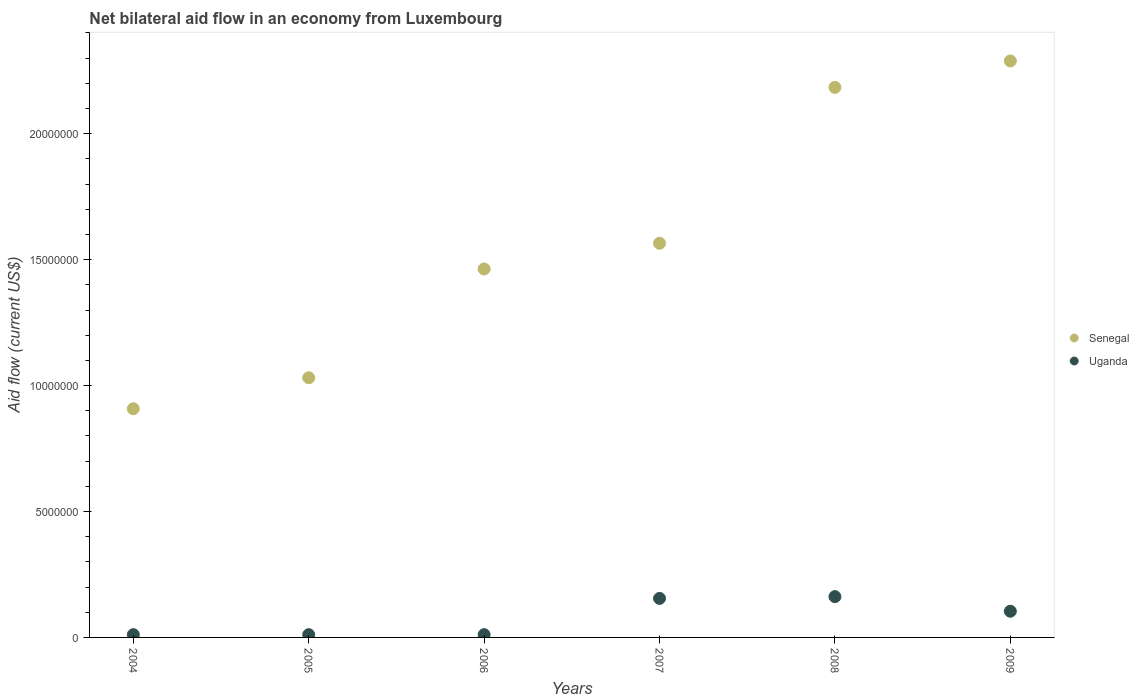How many different coloured dotlines are there?
Provide a succinct answer. 2. Is the number of dotlines equal to the number of legend labels?
Keep it short and to the point. Yes. What is the net bilateral aid flow in Senegal in 2008?
Ensure brevity in your answer.  2.18e+07. Across all years, what is the maximum net bilateral aid flow in Uganda?
Provide a short and direct response. 1.62e+06. Across all years, what is the minimum net bilateral aid flow in Senegal?
Your response must be concise. 9.08e+06. In which year was the net bilateral aid flow in Uganda minimum?
Offer a very short reply. 2004. What is the total net bilateral aid flow in Uganda in the graph?
Offer a very short reply. 4.54e+06. What is the difference between the net bilateral aid flow in Senegal in 2008 and that in 2009?
Make the answer very short. -1.05e+06. What is the difference between the net bilateral aid flow in Uganda in 2006 and the net bilateral aid flow in Senegal in 2009?
Keep it short and to the point. -2.28e+07. What is the average net bilateral aid flow in Uganda per year?
Offer a very short reply. 7.57e+05. In the year 2004, what is the difference between the net bilateral aid flow in Uganda and net bilateral aid flow in Senegal?
Provide a short and direct response. -8.97e+06. In how many years, is the net bilateral aid flow in Uganda greater than 17000000 US$?
Ensure brevity in your answer.  0. What is the ratio of the net bilateral aid flow in Uganda in 2004 to that in 2008?
Keep it short and to the point. 0.07. What is the difference between the highest and the second highest net bilateral aid flow in Senegal?
Provide a short and direct response. 1.05e+06. What is the difference between the highest and the lowest net bilateral aid flow in Senegal?
Provide a succinct answer. 1.38e+07. Is the sum of the net bilateral aid flow in Senegal in 2006 and 2008 greater than the maximum net bilateral aid flow in Uganda across all years?
Offer a terse response. Yes. Does the net bilateral aid flow in Uganda monotonically increase over the years?
Ensure brevity in your answer.  No. Is the net bilateral aid flow in Senegal strictly greater than the net bilateral aid flow in Uganda over the years?
Your answer should be very brief. Yes. How many dotlines are there?
Offer a terse response. 2. How many years are there in the graph?
Your answer should be compact. 6. Are the values on the major ticks of Y-axis written in scientific E-notation?
Provide a short and direct response. No. Does the graph contain any zero values?
Your answer should be very brief. No. Does the graph contain grids?
Ensure brevity in your answer.  No. How many legend labels are there?
Provide a short and direct response. 2. What is the title of the graph?
Your answer should be very brief. Net bilateral aid flow in an economy from Luxembourg. What is the label or title of the X-axis?
Give a very brief answer. Years. What is the label or title of the Y-axis?
Give a very brief answer. Aid flow (current US$). What is the Aid flow (current US$) of Senegal in 2004?
Your answer should be compact. 9.08e+06. What is the Aid flow (current US$) of Uganda in 2004?
Ensure brevity in your answer.  1.10e+05. What is the Aid flow (current US$) of Senegal in 2005?
Ensure brevity in your answer.  1.03e+07. What is the Aid flow (current US$) of Senegal in 2006?
Provide a succinct answer. 1.46e+07. What is the Aid flow (current US$) of Senegal in 2007?
Make the answer very short. 1.56e+07. What is the Aid flow (current US$) of Uganda in 2007?
Your answer should be very brief. 1.55e+06. What is the Aid flow (current US$) of Senegal in 2008?
Your answer should be very brief. 2.18e+07. What is the Aid flow (current US$) in Uganda in 2008?
Ensure brevity in your answer.  1.62e+06. What is the Aid flow (current US$) in Senegal in 2009?
Make the answer very short. 2.29e+07. What is the Aid flow (current US$) in Uganda in 2009?
Keep it short and to the point. 1.04e+06. Across all years, what is the maximum Aid flow (current US$) in Senegal?
Ensure brevity in your answer.  2.29e+07. Across all years, what is the maximum Aid flow (current US$) of Uganda?
Ensure brevity in your answer.  1.62e+06. Across all years, what is the minimum Aid flow (current US$) in Senegal?
Your answer should be compact. 9.08e+06. What is the total Aid flow (current US$) in Senegal in the graph?
Your response must be concise. 9.44e+07. What is the total Aid flow (current US$) of Uganda in the graph?
Provide a succinct answer. 4.54e+06. What is the difference between the Aid flow (current US$) in Senegal in 2004 and that in 2005?
Your answer should be very brief. -1.23e+06. What is the difference between the Aid flow (current US$) in Senegal in 2004 and that in 2006?
Keep it short and to the point. -5.55e+06. What is the difference between the Aid flow (current US$) of Senegal in 2004 and that in 2007?
Ensure brevity in your answer.  -6.57e+06. What is the difference between the Aid flow (current US$) in Uganda in 2004 and that in 2007?
Give a very brief answer. -1.44e+06. What is the difference between the Aid flow (current US$) of Senegal in 2004 and that in 2008?
Offer a terse response. -1.28e+07. What is the difference between the Aid flow (current US$) in Uganda in 2004 and that in 2008?
Ensure brevity in your answer.  -1.51e+06. What is the difference between the Aid flow (current US$) of Senegal in 2004 and that in 2009?
Make the answer very short. -1.38e+07. What is the difference between the Aid flow (current US$) of Uganda in 2004 and that in 2009?
Make the answer very short. -9.30e+05. What is the difference between the Aid flow (current US$) of Senegal in 2005 and that in 2006?
Give a very brief answer. -4.32e+06. What is the difference between the Aid flow (current US$) of Senegal in 2005 and that in 2007?
Give a very brief answer. -5.34e+06. What is the difference between the Aid flow (current US$) of Uganda in 2005 and that in 2007?
Give a very brief answer. -1.44e+06. What is the difference between the Aid flow (current US$) in Senegal in 2005 and that in 2008?
Provide a succinct answer. -1.15e+07. What is the difference between the Aid flow (current US$) of Uganda in 2005 and that in 2008?
Provide a short and direct response. -1.51e+06. What is the difference between the Aid flow (current US$) of Senegal in 2005 and that in 2009?
Offer a very short reply. -1.26e+07. What is the difference between the Aid flow (current US$) in Uganda in 2005 and that in 2009?
Keep it short and to the point. -9.30e+05. What is the difference between the Aid flow (current US$) of Senegal in 2006 and that in 2007?
Keep it short and to the point. -1.02e+06. What is the difference between the Aid flow (current US$) in Uganda in 2006 and that in 2007?
Ensure brevity in your answer.  -1.44e+06. What is the difference between the Aid flow (current US$) of Senegal in 2006 and that in 2008?
Give a very brief answer. -7.21e+06. What is the difference between the Aid flow (current US$) in Uganda in 2006 and that in 2008?
Provide a succinct answer. -1.51e+06. What is the difference between the Aid flow (current US$) in Senegal in 2006 and that in 2009?
Offer a terse response. -8.26e+06. What is the difference between the Aid flow (current US$) of Uganda in 2006 and that in 2009?
Your answer should be very brief. -9.30e+05. What is the difference between the Aid flow (current US$) of Senegal in 2007 and that in 2008?
Offer a terse response. -6.19e+06. What is the difference between the Aid flow (current US$) of Senegal in 2007 and that in 2009?
Your response must be concise. -7.24e+06. What is the difference between the Aid flow (current US$) of Uganda in 2007 and that in 2009?
Make the answer very short. 5.10e+05. What is the difference between the Aid flow (current US$) of Senegal in 2008 and that in 2009?
Keep it short and to the point. -1.05e+06. What is the difference between the Aid flow (current US$) of Uganda in 2008 and that in 2009?
Make the answer very short. 5.80e+05. What is the difference between the Aid flow (current US$) of Senegal in 2004 and the Aid flow (current US$) of Uganda in 2005?
Provide a succinct answer. 8.97e+06. What is the difference between the Aid flow (current US$) in Senegal in 2004 and the Aid flow (current US$) in Uganda in 2006?
Your response must be concise. 8.97e+06. What is the difference between the Aid flow (current US$) in Senegal in 2004 and the Aid flow (current US$) in Uganda in 2007?
Make the answer very short. 7.53e+06. What is the difference between the Aid flow (current US$) of Senegal in 2004 and the Aid flow (current US$) of Uganda in 2008?
Give a very brief answer. 7.46e+06. What is the difference between the Aid flow (current US$) of Senegal in 2004 and the Aid flow (current US$) of Uganda in 2009?
Your answer should be very brief. 8.04e+06. What is the difference between the Aid flow (current US$) of Senegal in 2005 and the Aid flow (current US$) of Uganda in 2006?
Provide a short and direct response. 1.02e+07. What is the difference between the Aid flow (current US$) of Senegal in 2005 and the Aid flow (current US$) of Uganda in 2007?
Your answer should be very brief. 8.76e+06. What is the difference between the Aid flow (current US$) in Senegal in 2005 and the Aid flow (current US$) in Uganda in 2008?
Provide a succinct answer. 8.69e+06. What is the difference between the Aid flow (current US$) in Senegal in 2005 and the Aid flow (current US$) in Uganda in 2009?
Your answer should be very brief. 9.27e+06. What is the difference between the Aid flow (current US$) in Senegal in 2006 and the Aid flow (current US$) in Uganda in 2007?
Keep it short and to the point. 1.31e+07. What is the difference between the Aid flow (current US$) in Senegal in 2006 and the Aid flow (current US$) in Uganda in 2008?
Provide a short and direct response. 1.30e+07. What is the difference between the Aid flow (current US$) of Senegal in 2006 and the Aid flow (current US$) of Uganda in 2009?
Give a very brief answer. 1.36e+07. What is the difference between the Aid flow (current US$) of Senegal in 2007 and the Aid flow (current US$) of Uganda in 2008?
Provide a succinct answer. 1.40e+07. What is the difference between the Aid flow (current US$) of Senegal in 2007 and the Aid flow (current US$) of Uganda in 2009?
Your response must be concise. 1.46e+07. What is the difference between the Aid flow (current US$) of Senegal in 2008 and the Aid flow (current US$) of Uganda in 2009?
Offer a terse response. 2.08e+07. What is the average Aid flow (current US$) of Senegal per year?
Provide a short and direct response. 1.57e+07. What is the average Aid flow (current US$) of Uganda per year?
Your answer should be compact. 7.57e+05. In the year 2004, what is the difference between the Aid flow (current US$) of Senegal and Aid flow (current US$) of Uganda?
Ensure brevity in your answer.  8.97e+06. In the year 2005, what is the difference between the Aid flow (current US$) of Senegal and Aid flow (current US$) of Uganda?
Provide a succinct answer. 1.02e+07. In the year 2006, what is the difference between the Aid flow (current US$) in Senegal and Aid flow (current US$) in Uganda?
Ensure brevity in your answer.  1.45e+07. In the year 2007, what is the difference between the Aid flow (current US$) in Senegal and Aid flow (current US$) in Uganda?
Your response must be concise. 1.41e+07. In the year 2008, what is the difference between the Aid flow (current US$) of Senegal and Aid flow (current US$) of Uganda?
Provide a succinct answer. 2.02e+07. In the year 2009, what is the difference between the Aid flow (current US$) of Senegal and Aid flow (current US$) of Uganda?
Your answer should be compact. 2.18e+07. What is the ratio of the Aid flow (current US$) of Senegal in 2004 to that in 2005?
Your response must be concise. 0.88. What is the ratio of the Aid flow (current US$) in Uganda in 2004 to that in 2005?
Offer a very short reply. 1. What is the ratio of the Aid flow (current US$) of Senegal in 2004 to that in 2006?
Your answer should be compact. 0.62. What is the ratio of the Aid flow (current US$) of Senegal in 2004 to that in 2007?
Provide a short and direct response. 0.58. What is the ratio of the Aid flow (current US$) in Uganda in 2004 to that in 2007?
Your answer should be compact. 0.07. What is the ratio of the Aid flow (current US$) in Senegal in 2004 to that in 2008?
Ensure brevity in your answer.  0.42. What is the ratio of the Aid flow (current US$) of Uganda in 2004 to that in 2008?
Keep it short and to the point. 0.07. What is the ratio of the Aid flow (current US$) in Senegal in 2004 to that in 2009?
Provide a succinct answer. 0.4. What is the ratio of the Aid flow (current US$) in Uganda in 2004 to that in 2009?
Your answer should be compact. 0.11. What is the ratio of the Aid flow (current US$) in Senegal in 2005 to that in 2006?
Make the answer very short. 0.7. What is the ratio of the Aid flow (current US$) of Uganda in 2005 to that in 2006?
Offer a terse response. 1. What is the ratio of the Aid flow (current US$) of Senegal in 2005 to that in 2007?
Your response must be concise. 0.66. What is the ratio of the Aid flow (current US$) in Uganda in 2005 to that in 2007?
Your response must be concise. 0.07. What is the ratio of the Aid flow (current US$) of Senegal in 2005 to that in 2008?
Your answer should be very brief. 0.47. What is the ratio of the Aid flow (current US$) in Uganda in 2005 to that in 2008?
Offer a terse response. 0.07. What is the ratio of the Aid flow (current US$) of Senegal in 2005 to that in 2009?
Keep it short and to the point. 0.45. What is the ratio of the Aid flow (current US$) of Uganda in 2005 to that in 2009?
Make the answer very short. 0.11. What is the ratio of the Aid flow (current US$) in Senegal in 2006 to that in 2007?
Give a very brief answer. 0.93. What is the ratio of the Aid flow (current US$) of Uganda in 2006 to that in 2007?
Ensure brevity in your answer.  0.07. What is the ratio of the Aid flow (current US$) of Senegal in 2006 to that in 2008?
Offer a very short reply. 0.67. What is the ratio of the Aid flow (current US$) of Uganda in 2006 to that in 2008?
Offer a very short reply. 0.07. What is the ratio of the Aid flow (current US$) of Senegal in 2006 to that in 2009?
Your answer should be very brief. 0.64. What is the ratio of the Aid flow (current US$) in Uganda in 2006 to that in 2009?
Offer a terse response. 0.11. What is the ratio of the Aid flow (current US$) of Senegal in 2007 to that in 2008?
Make the answer very short. 0.72. What is the ratio of the Aid flow (current US$) in Uganda in 2007 to that in 2008?
Provide a succinct answer. 0.96. What is the ratio of the Aid flow (current US$) of Senegal in 2007 to that in 2009?
Provide a short and direct response. 0.68. What is the ratio of the Aid flow (current US$) of Uganda in 2007 to that in 2009?
Keep it short and to the point. 1.49. What is the ratio of the Aid flow (current US$) of Senegal in 2008 to that in 2009?
Offer a very short reply. 0.95. What is the ratio of the Aid flow (current US$) in Uganda in 2008 to that in 2009?
Offer a terse response. 1.56. What is the difference between the highest and the second highest Aid flow (current US$) of Senegal?
Your response must be concise. 1.05e+06. What is the difference between the highest and the second highest Aid flow (current US$) in Uganda?
Make the answer very short. 7.00e+04. What is the difference between the highest and the lowest Aid flow (current US$) of Senegal?
Give a very brief answer. 1.38e+07. What is the difference between the highest and the lowest Aid flow (current US$) in Uganda?
Keep it short and to the point. 1.51e+06. 